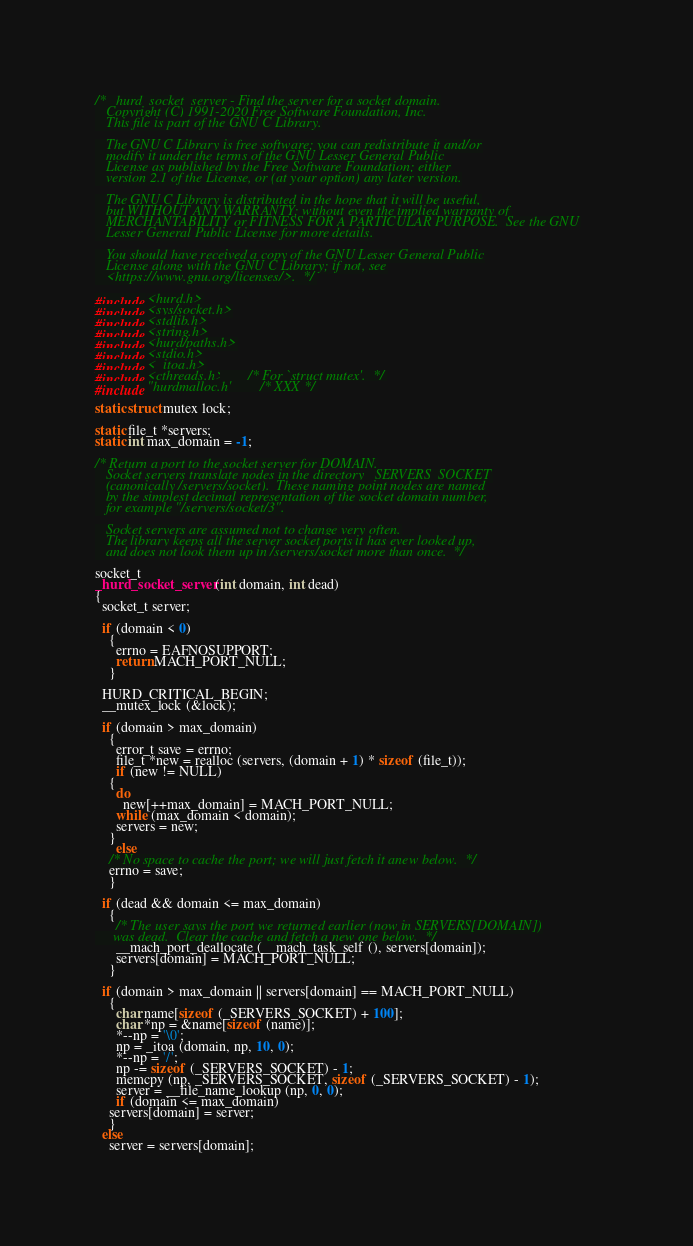<code> <loc_0><loc_0><loc_500><loc_500><_C_>/* _hurd_socket_server - Find the server for a socket domain.
   Copyright (C) 1991-2020 Free Software Foundation, Inc.
   This file is part of the GNU C Library.

   The GNU C Library is free software; you can redistribute it and/or
   modify it under the terms of the GNU Lesser General Public
   License as published by the Free Software Foundation; either
   version 2.1 of the License, or (at your option) any later version.

   The GNU C Library is distributed in the hope that it will be useful,
   but WITHOUT ANY WARRANTY; without even the implied warranty of
   MERCHANTABILITY or FITNESS FOR A PARTICULAR PURPOSE.  See the GNU
   Lesser General Public License for more details.

   You should have received a copy of the GNU Lesser General Public
   License along with the GNU C Library; if not, see
   <https://www.gnu.org/licenses/>.  */

#include <hurd.h>
#include <sys/socket.h>
#include <stdlib.h>
#include <string.h>
#include <hurd/paths.h>
#include <stdio.h>
#include <_itoa.h>
#include <cthreads.h>		/* For `struct mutex'.  */
#include "hurdmalloc.h"		/* XXX */

static struct mutex lock;

static file_t *servers;
static int max_domain = -1;

/* Return a port to the socket server for DOMAIN.
   Socket servers translate nodes in the directory _SERVERS_SOCKET
   (canonically /servers/socket).  These naming point nodes are named
   by the simplest decimal representation of the socket domain number,
   for example "/servers/socket/3".

   Socket servers are assumed not to change very often.
   The library keeps all the server socket ports it has ever looked up,
   and does not look them up in /servers/socket more than once.  */

socket_t
_hurd_socket_server (int domain, int dead)
{
  socket_t server;

  if (domain < 0)
    {
      errno = EAFNOSUPPORT;
      return MACH_PORT_NULL;
    }

  HURD_CRITICAL_BEGIN;
  __mutex_lock (&lock);

  if (domain > max_domain)
    {
      error_t save = errno;
      file_t *new = realloc (servers, (domain + 1) * sizeof (file_t));
      if (new != NULL)
	{
	  do
	    new[++max_domain] = MACH_PORT_NULL;
	  while (max_domain < domain);
	  servers = new;
	}
      else
	/* No space to cache the port; we will just fetch it anew below.  */
	errno = save;
    }

  if (dead && domain <= max_domain)
    {
      /* The user says the port we returned earlier (now in SERVERS[DOMAIN])
	 was dead.  Clear the cache and fetch a new one below.  */
      __mach_port_deallocate (__mach_task_self (), servers[domain]);
      servers[domain] = MACH_PORT_NULL;
    }

  if (domain > max_domain || servers[domain] == MACH_PORT_NULL)
    {
      char name[sizeof (_SERVERS_SOCKET) + 100];
      char *np = &name[sizeof (name)];
      *--np = '\0';
      np = _itoa (domain, np, 10, 0);
      *--np = '/';
      np -= sizeof (_SERVERS_SOCKET) - 1;
      memcpy (np, _SERVERS_SOCKET, sizeof (_SERVERS_SOCKET) - 1);
      server = __file_name_lookup (np, 0, 0);
      if (domain <= max_domain)
	servers[domain] = server;
    }
  else
    server = servers[domain];
</code> 